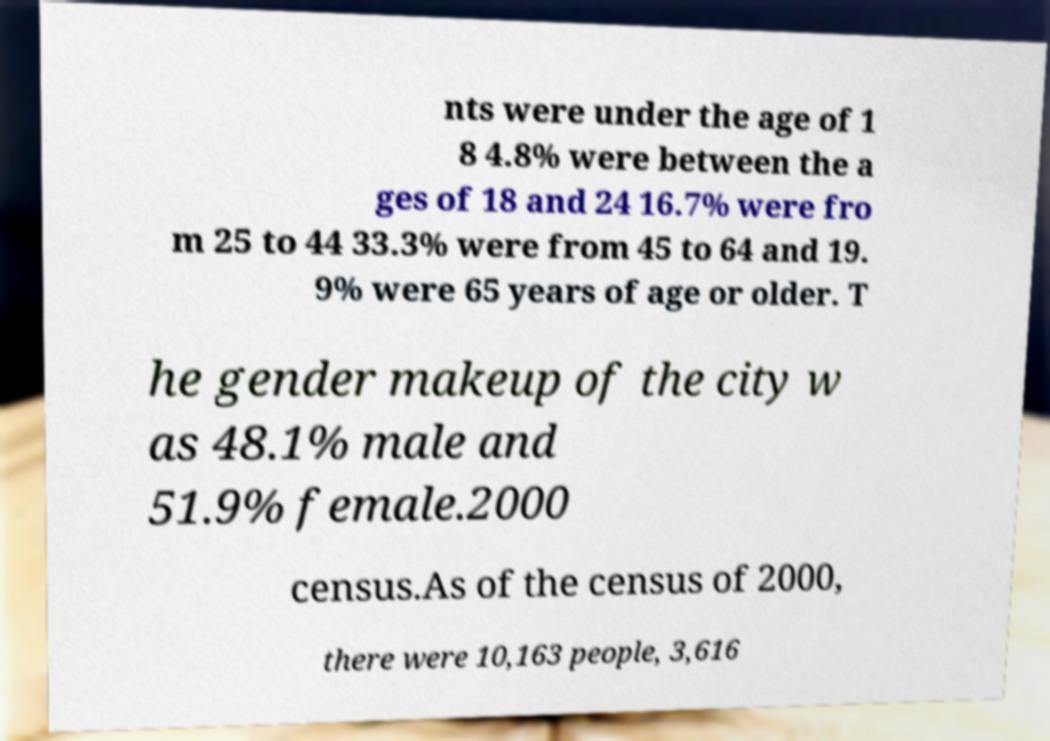I need the written content from this picture converted into text. Can you do that? nts were under the age of 1 8 4.8% were between the a ges of 18 and 24 16.7% were fro m 25 to 44 33.3% were from 45 to 64 and 19. 9% were 65 years of age or older. T he gender makeup of the city w as 48.1% male and 51.9% female.2000 census.As of the census of 2000, there were 10,163 people, 3,616 